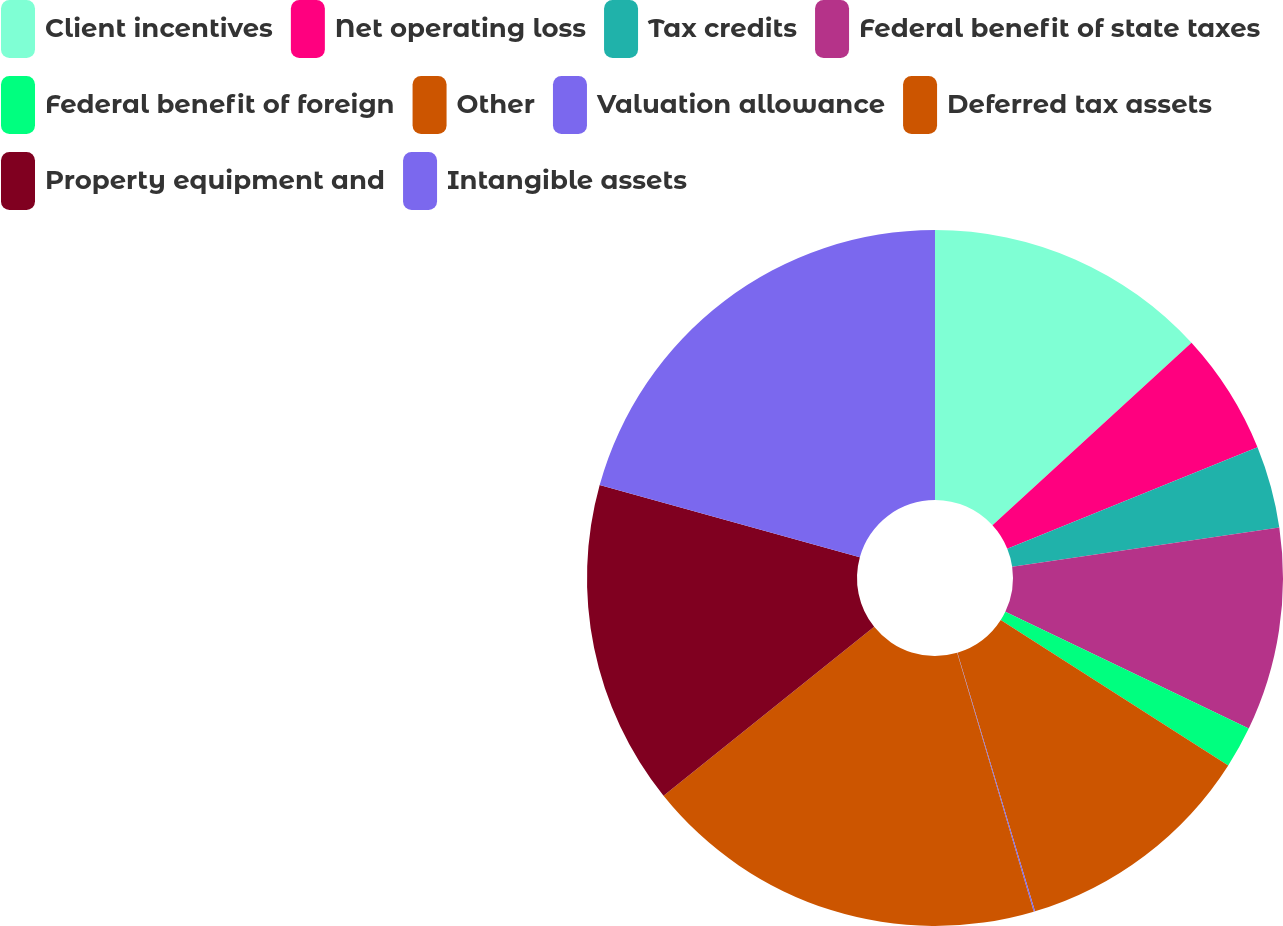<chart> <loc_0><loc_0><loc_500><loc_500><pie_chart><fcel>Client incentives<fcel>Net operating loss<fcel>Tax credits<fcel>Federal benefit of state taxes<fcel>Federal benefit of foreign<fcel>Other<fcel>Valuation allowance<fcel>Deferred tax assets<fcel>Property equipment and<fcel>Intangible assets<nl><fcel>13.19%<fcel>5.68%<fcel>3.81%<fcel>9.44%<fcel>1.93%<fcel>11.31%<fcel>0.06%<fcel>18.82%<fcel>15.07%<fcel>20.69%<nl></chart> 